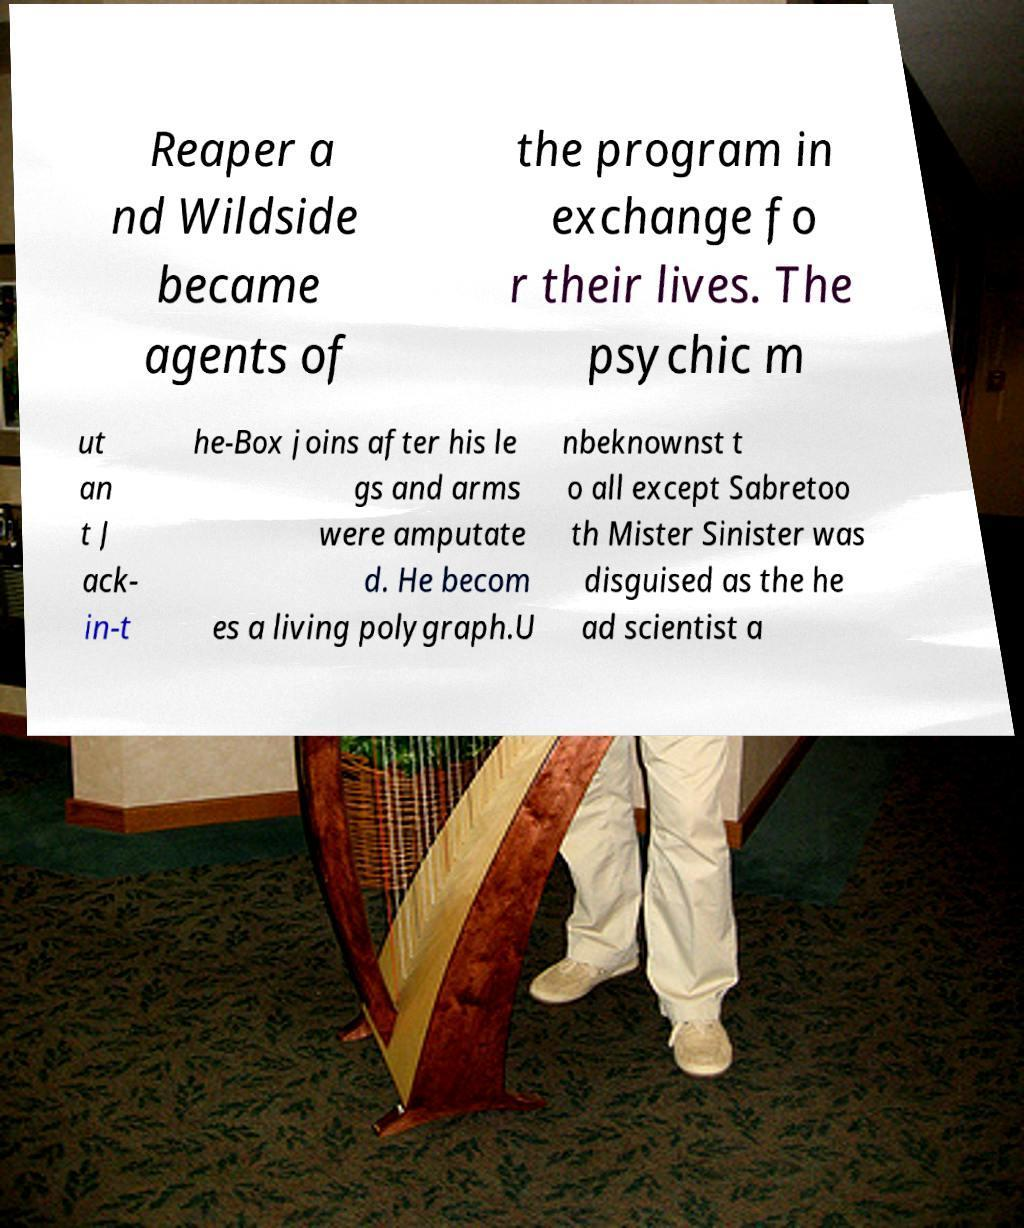Please identify and transcribe the text found in this image. Reaper a nd Wildside became agents of the program in exchange fo r their lives. The psychic m ut an t J ack- in-t he-Box joins after his le gs and arms were amputate d. He becom es a living polygraph.U nbeknownst t o all except Sabretoo th Mister Sinister was disguised as the he ad scientist a 